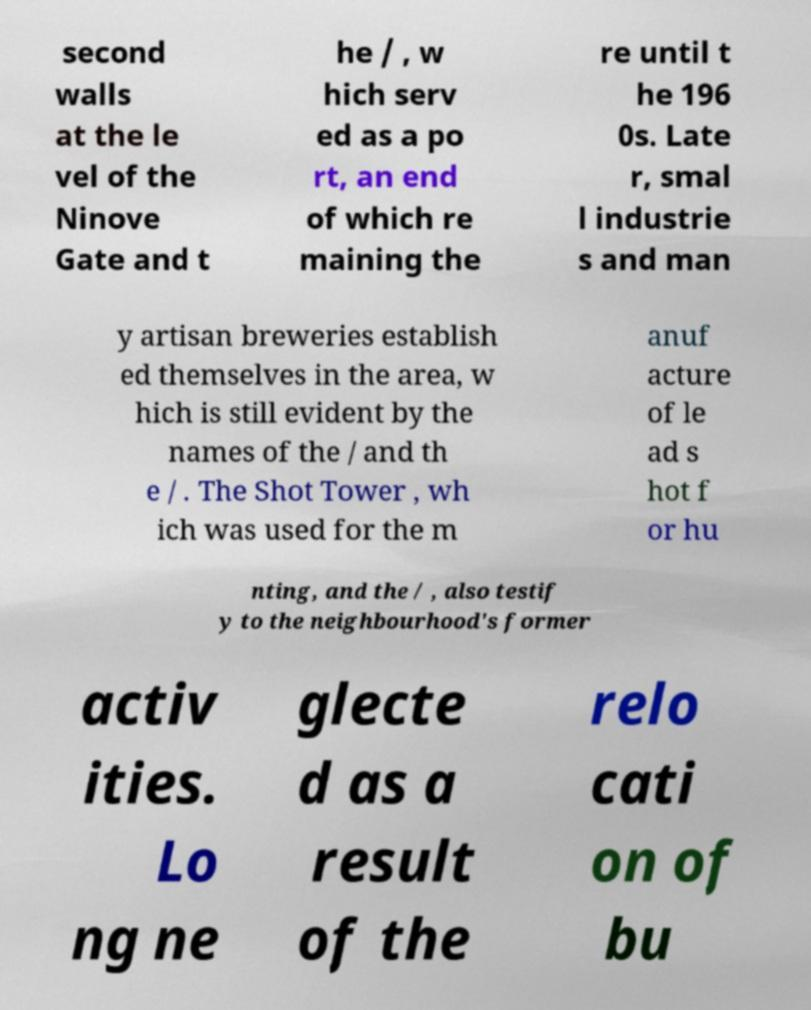What messages or text are displayed in this image? I need them in a readable, typed format. second walls at the le vel of the Ninove Gate and t he / , w hich serv ed as a po rt, an end of which re maining the re until t he 196 0s. Late r, smal l industrie s and man y artisan breweries establish ed themselves in the area, w hich is still evident by the names of the / and th e / . The Shot Tower , wh ich was used for the m anuf acture of le ad s hot f or hu nting, and the / , also testif y to the neighbourhood's former activ ities. Lo ng ne glecte d as a result of the relo cati on of bu 